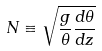Convert formula to latex. <formula><loc_0><loc_0><loc_500><loc_500>N \equiv \sqrt { \frac { g } { \theta } \frac { d \theta } { d z } }</formula> 